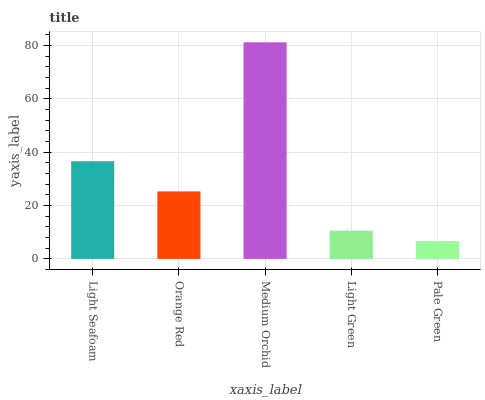Is Orange Red the minimum?
Answer yes or no. No. Is Orange Red the maximum?
Answer yes or no. No. Is Light Seafoam greater than Orange Red?
Answer yes or no. Yes. Is Orange Red less than Light Seafoam?
Answer yes or no. Yes. Is Orange Red greater than Light Seafoam?
Answer yes or no. No. Is Light Seafoam less than Orange Red?
Answer yes or no. No. Is Orange Red the high median?
Answer yes or no. Yes. Is Orange Red the low median?
Answer yes or no. Yes. Is Light Seafoam the high median?
Answer yes or no. No. Is Pale Green the low median?
Answer yes or no. No. 